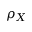Convert formula to latex. <formula><loc_0><loc_0><loc_500><loc_500>\rho _ { X }</formula> 